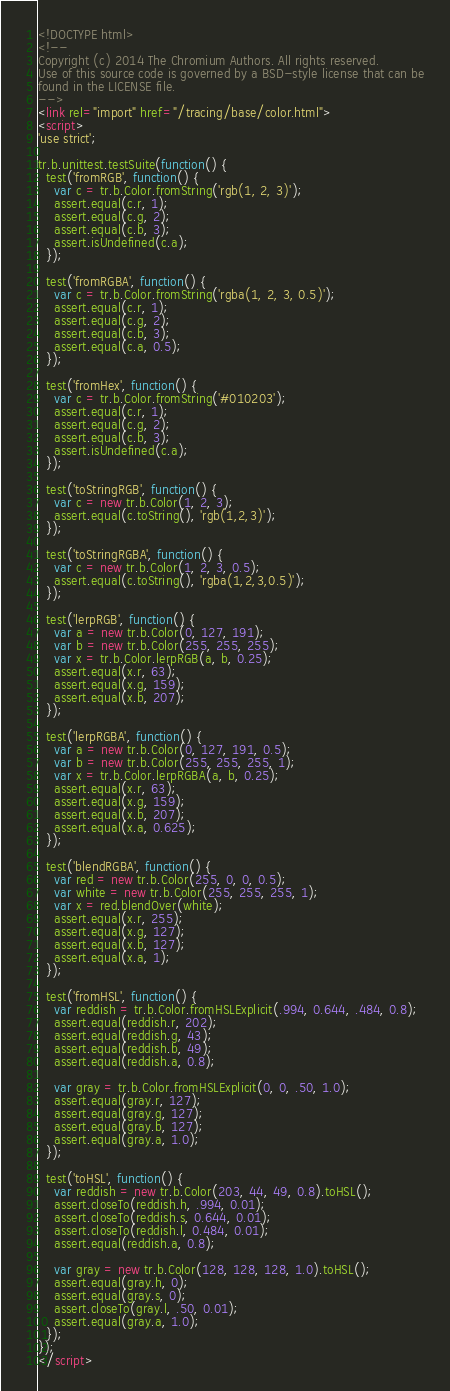<code> <loc_0><loc_0><loc_500><loc_500><_HTML_><!DOCTYPE html>
<!--
Copyright (c) 2014 The Chromium Authors. All rights reserved.
Use of this source code is governed by a BSD-style license that can be
found in the LICENSE file.
-->
<link rel="import" href="/tracing/base/color.html">
<script>
'use strict';

tr.b.unittest.testSuite(function() {
  test('fromRGB', function() {
    var c = tr.b.Color.fromString('rgb(1, 2, 3)');
    assert.equal(c.r, 1);
    assert.equal(c.g, 2);
    assert.equal(c.b, 3);
    assert.isUndefined(c.a);
  });

  test('fromRGBA', function() {
    var c = tr.b.Color.fromString('rgba(1, 2, 3, 0.5)');
    assert.equal(c.r, 1);
    assert.equal(c.g, 2);
    assert.equal(c.b, 3);
    assert.equal(c.a, 0.5);
  });

  test('fromHex', function() {
    var c = tr.b.Color.fromString('#010203');
    assert.equal(c.r, 1);
    assert.equal(c.g, 2);
    assert.equal(c.b, 3);
    assert.isUndefined(c.a);
  });

  test('toStringRGB', function() {
    var c = new tr.b.Color(1, 2, 3);
    assert.equal(c.toString(), 'rgb(1,2,3)');
  });

  test('toStringRGBA', function() {
    var c = new tr.b.Color(1, 2, 3, 0.5);
    assert.equal(c.toString(), 'rgba(1,2,3,0.5)');
  });

  test('lerpRGB', function() {
    var a = new tr.b.Color(0, 127, 191);
    var b = new tr.b.Color(255, 255, 255);
    var x = tr.b.Color.lerpRGB(a, b, 0.25);
    assert.equal(x.r, 63);
    assert.equal(x.g, 159);
    assert.equal(x.b, 207);
  });

  test('lerpRGBA', function() {
    var a = new tr.b.Color(0, 127, 191, 0.5);
    var b = new tr.b.Color(255, 255, 255, 1);
    var x = tr.b.Color.lerpRGBA(a, b, 0.25);
    assert.equal(x.r, 63);
    assert.equal(x.g, 159);
    assert.equal(x.b, 207);
    assert.equal(x.a, 0.625);
  });

  test('blendRGBA', function() {
    var red = new tr.b.Color(255, 0, 0, 0.5);
    var white = new tr.b.Color(255, 255, 255, 1);
    var x = red.blendOver(white);
    assert.equal(x.r, 255);
    assert.equal(x.g, 127);
    assert.equal(x.b, 127);
    assert.equal(x.a, 1);
  });

  test('fromHSL', function() {
    var reddish = tr.b.Color.fromHSLExplicit(.994, 0.644, .484, 0.8);
    assert.equal(reddish.r, 202);
    assert.equal(reddish.g, 43);
    assert.equal(reddish.b, 49);
    assert.equal(reddish.a, 0.8);

    var gray = tr.b.Color.fromHSLExplicit(0, 0, .50, 1.0);
    assert.equal(gray.r, 127);
    assert.equal(gray.g, 127);
    assert.equal(gray.b, 127);
    assert.equal(gray.a, 1.0);
  });

  test('toHSL', function() {
    var reddish = new tr.b.Color(203, 44, 49, 0.8).toHSL();
    assert.closeTo(reddish.h, .994, 0.01);
    assert.closeTo(reddish.s, 0.644, 0.01);
    assert.closeTo(reddish.l, 0.484, 0.01);
    assert.equal(reddish.a, 0.8);

    var gray = new tr.b.Color(128, 128, 128, 1.0).toHSL();
    assert.equal(gray.h, 0);
    assert.equal(gray.s, 0);
    assert.closeTo(gray.l, .50, 0.01);
    assert.equal(gray.a, 1.0);
  });
});
</script>
</code> 